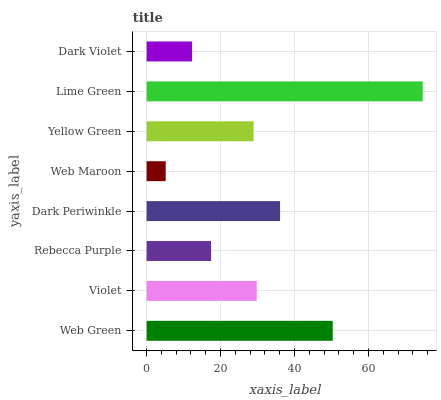Is Web Maroon the minimum?
Answer yes or no. Yes. Is Lime Green the maximum?
Answer yes or no. Yes. Is Violet the minimum?
Answer yes or no. No. Is Violet the maximum?
Answer yes or no. No. Is Web Green greater than Violet?
Answer yes or no. Yes. Is Violet less than Web Green?
Answer yes or no. Yes. Is Violet greater than Web Green?
Answer yes or no. No. Is Web Green less than Violet?
Answer yes or no. No. Is Violet the high median?
Answer yes or no. Yes. Is Yellow Green the low median?
Answer yes or no. Yes. Is Web Maroon the high median?
Answer yes or no. No. Is Web Green the low median?
Answer yes or no. No. 